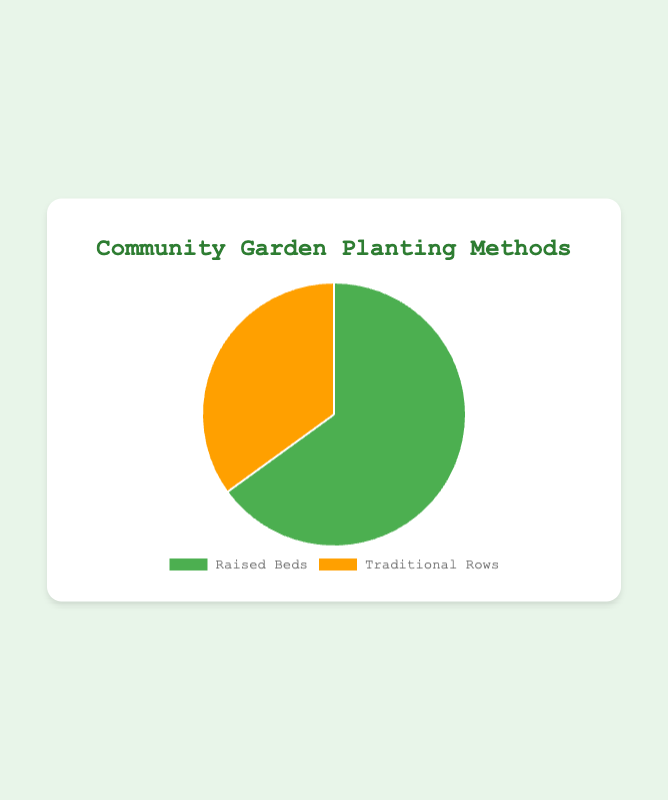what percentage of the pie chart is represented by Raised Beds? The pie chart shows that Raised Beds make up 65% of the chart, which means they represent 65% of the total vegetable planting methods.
Answer: 65% what percentage of the pie chart is represented by Traditional Rows? The pie chart shows that Traditional Rows make up 35% of the chart, which means they represent 35% of the total vegetable planting methods.
Answer: 35% which planting method is more common, Raised Beds or Traditional Rows? By comparing the two percentages provided in the pie chart, it is evident that Raised Beds (65%) are more common than Traditional Rows (35%).
Answer: Raised Beds what is the difference in percentage between the Raised Beds and Traditional Rows methods? The difference in percentage is calculated by subtracting the smaller percentage (Traditional Rows) from the larger percentage (Raised Beds): 65% - 35% = 30%.
Answer: 30% what color represents the Traditional Rows method in the pie chart? The Traditional Rows method is represented by the orange slice in the pie chart.
Answer: orange which method occupies a larger portion of the pie chart? The sightly larger slice of the pie chart is for Raised Beds, as it accounts for 65% compared to 35% for Traditional Rows.
Answer: Raised Beds if there were 200 plants in the garden, how many would be planted using the Traditional Rows method? First, calculate the number of plants using the Traditional Rows method: 35% of 200 is calculated as 200 * 0.35 = 70 plants.
Answer: 70 what is the ratio of plants using Raised Beds to those using Traditional Rows? The ratio can be determined by comparing the percentages. Raised Beds (65%) to Traditional Rows (35%) simplifies to 65:35, which can be further simplified to 13:7.
Answer: 13:7 if the percentage of Raised Beds increased by 5%, what would be the new percentage for Traditional Rows, assuming the total remains 100%? If Raised Beds increase to 70%, then Traditional Rows would decrease to 30% as the sum must equal 100%.
Answer: 30% how much more prevalent are Raised Beds compared to Traditional Rows in percentage terms? The prevalence is measured by the percentage difference between Raised Beds and Traditional Rows: 65% - 35% = 30% more prevalent.
Answer: 30% 